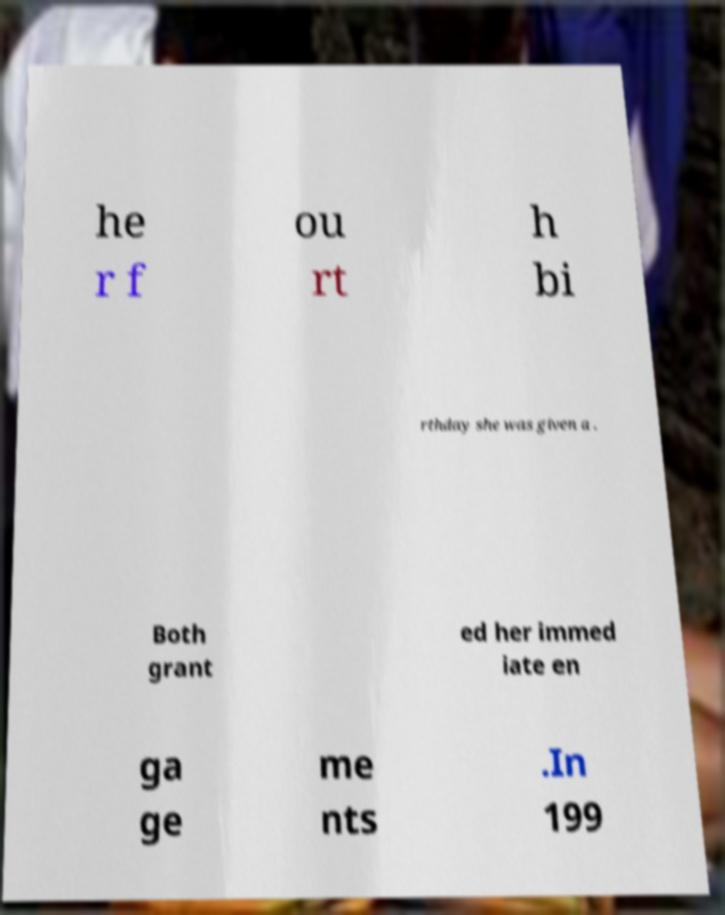Can you read and provide the text displayed in the image?This photo seems to have some interesting text. Can you extract and type it out for me? he r f ou rt h bi rthday she was given a . Both grant ed her immed iate en ga ge me nts .In 199 